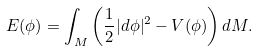Convert formula to latex. <formula><loc_0><loc_0><loc_500><loc_500>E ( \phi ) = \int _ { M } \left ( \frac { 1 } { 2 } | d \phi | ^ { 2 } - V ( \phi ) \right ) d M .</formula> 